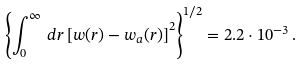<formula> <loc_0><loc_0><loc_500><loc_500>\left \{ \int _ { 0 } ^ { \infty } \, d r \left [ w ( r ) - w _ { a } ( r ) \right ] ^ { 2 } \right \} ^ { 1 / 2 } = 2 . 2 \cdot 1 0 ^ { - 3 } \, .</formula> 